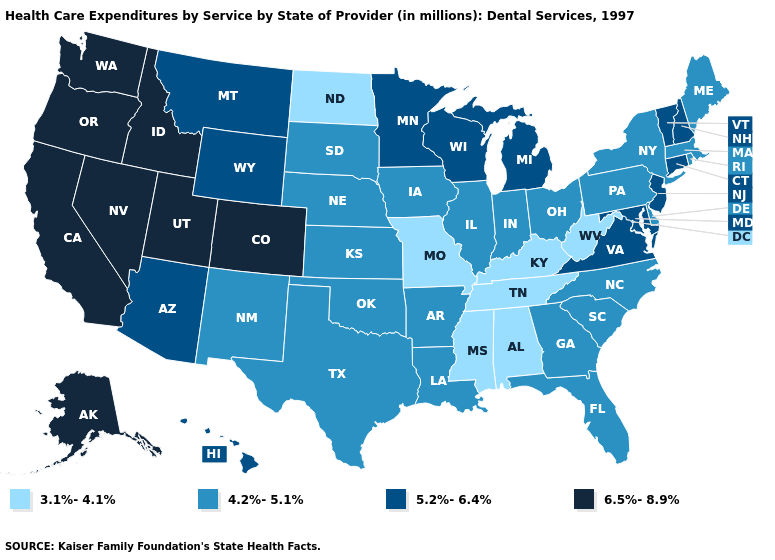What is the highest value in the USA?
Answer briefly. 6.5%-8.9%. What is the value of Vermont?
Keep it brief. 5.2%-6.4%. Name the states that have a value in the range 5.2%-6.4%?
Short answer required. Arizona, Connecticut, Hawaii, Maryland, Michigan, Minnesota, Montana, New Hampshire, New Jersey, Vermont, Virginia, Wisconsin, Wyoming. Does Maine have the lowest value in the Northeast?
Answer briefly. Yes. Name the states that have a value in the range 5.2%-6.4%?
Quick response, please. Arizona, Connecticut, Hawaii, Maryland, Michigan, Minnesota, Montana, New Hampshire, New Jersey, Vermont, Virginia, Wisconsin, Wyoming. What is the value of Delaware?
Concise answer only. 4.2%-5.1%. What is the lowest value in the USA?
Answer briefly. 3.1%-4.1%. Name the states that have a value in the range 3.1%-4.1%?
Keep it brief. Alabama, Kentucky, Mississippi, Missouri, North Dakota, Tennessee, West Virginia. Does Vermont have a lower value than Oregon?
Be succinct. Yes. What is the value of Nebraska?
Give a very brief answer. 4.2%-5.1%. Which states hav the highest value in the Northeast?
Short answer required. Connecticut, New Hampshire, New Jersey, Vermont. What is the value of Maryland?
Keep it brief. 5.2%-6.4%. What is the value of Vermont?
Give a very brief answer. 5.2%-6.4%. What is the value of Iowa?
Keep it brief. 4.2%-5.1%. Which states have the highest value in the USA?
Short answer required. Alaska, California, Colorado, Idaho, Nevada, Oregon, Utah, Washington. 